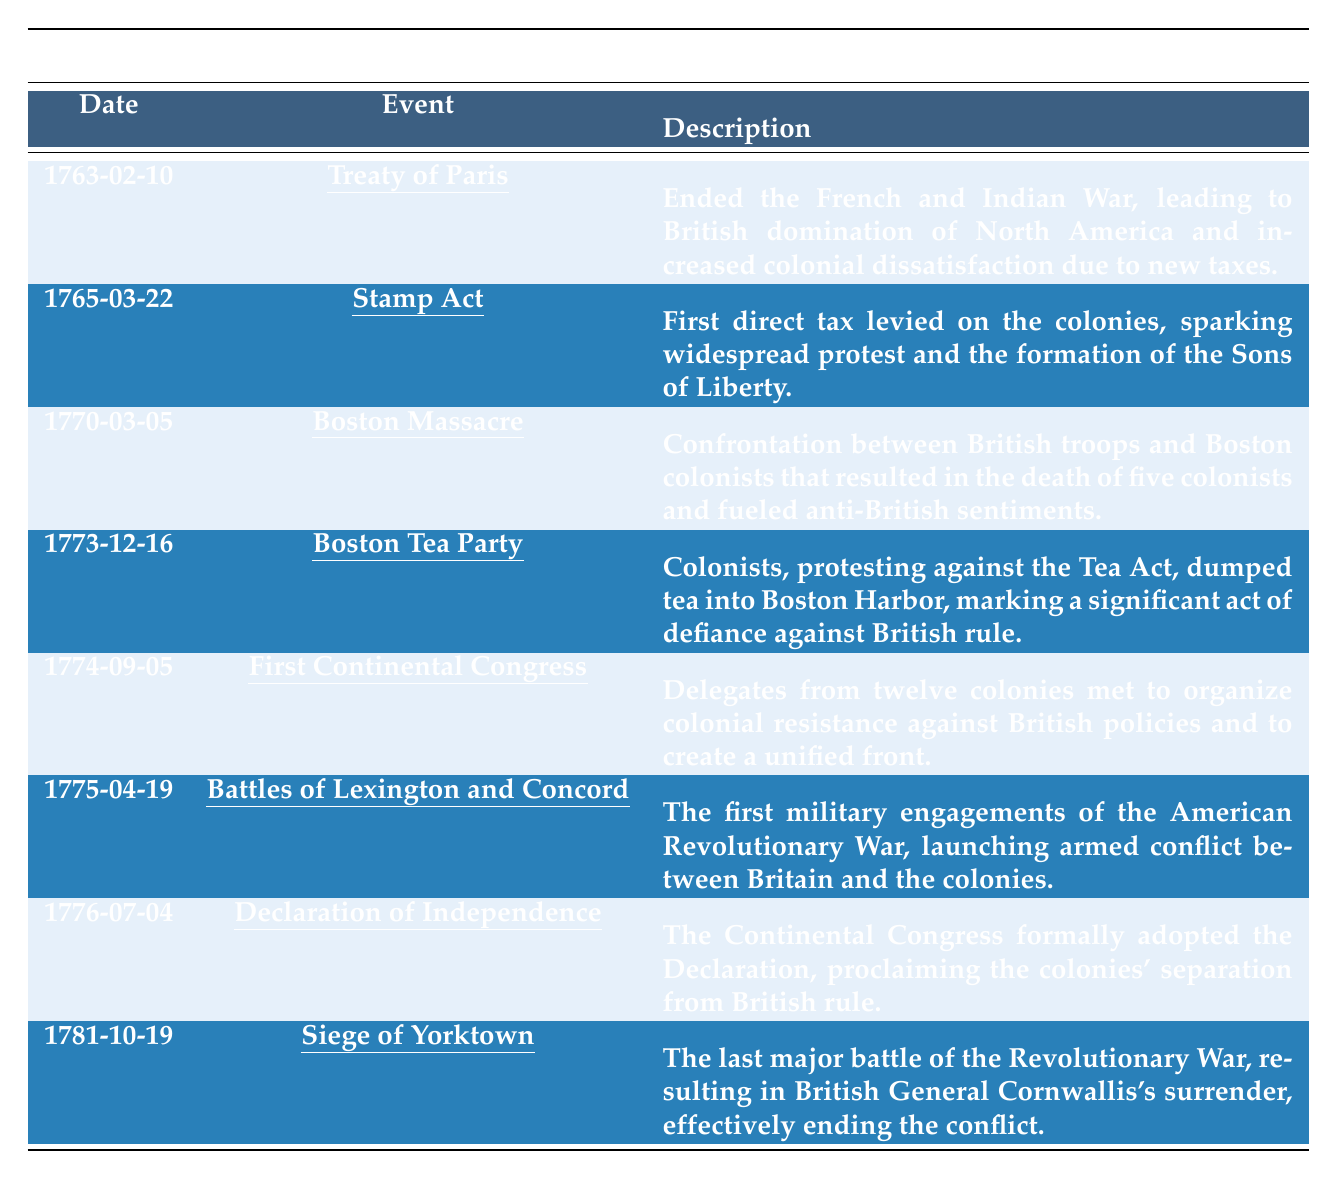What event occurred on March 22, 1765? Referring to the table, the date March 22, 1765, corresponds to the "Stamp Act."
Answer: Stamp Act Which event marked the first military engagements of the American Revolutionary War? The table specifies that the "Battles of Lexington and Concord," occurring on April 19, 1775, were the first military engagements of the war.
Answer: Battles of Lexington and Concord How many significant events are listed before the Declaration of Independence? The table lists eight significant events, with the Declaration of Independence being the seventh event, so there are six events listed before it.
Answer: Six Did the Boston Tea Party occur before or after the Boston Massacre? The date of the Boston Tea Party is December 16, 1773, and the Boston Massacre occurred earlier on March 5, 1770; hence, the Boston Tea Party occurred after.
Answer: After What description accompanies the event marked as the Siege of Yorktown? Looking at the row for the Siege of Yorktown, the description states that it was the last major battle of the Revolutionary War, resulting in British General Cornwallis’s surrender.
Answer: Last major battle of the Revolutionary War Which event is associated with increased colonial dissatisfaction, and what was its date? The "Treaty of Paris," dated February 10, 1763, is associated with increased colonial dissatisfaction due to British taxation following the end of the French and Indian War.
Answer: Treaty of Paris, February 10, 1763 How many years passed between the Treaty of Paris and the Declaration of Independence? The Treaty of Paris was in 1763, and the Declaration of Independence was adopted in 1776, so the number of years between them is 1776 - 1763 = 13 years.
Answer: 13 years Was the First Continental Congress held before or after the Boston Tea Party? The First Continental Congress took place on September 5, 1774, which is before the Boston Tea Party on December 16, 1773.
Answer: Before What can be inferred about colonial unity from the events leading to the Declaration of Independence? The significant events, particularly the formation of the First Continental Congress in 1774, indicate a growing sense of unity among the colonies against British rule, as they organized resistance and took collective action.
Answer: Growing sense of unity Which two events directly preceded the adoption of the Declaration of Independence? The two events directly preceding the Declaration of Independence were the "First Continental Congress" in September 1774 and the "Battles of Lexington and Concord" in April 1775, leading to increased revolutionary sentiment.
Answer: First Continental Congress and Battles of Lexington and Concord 